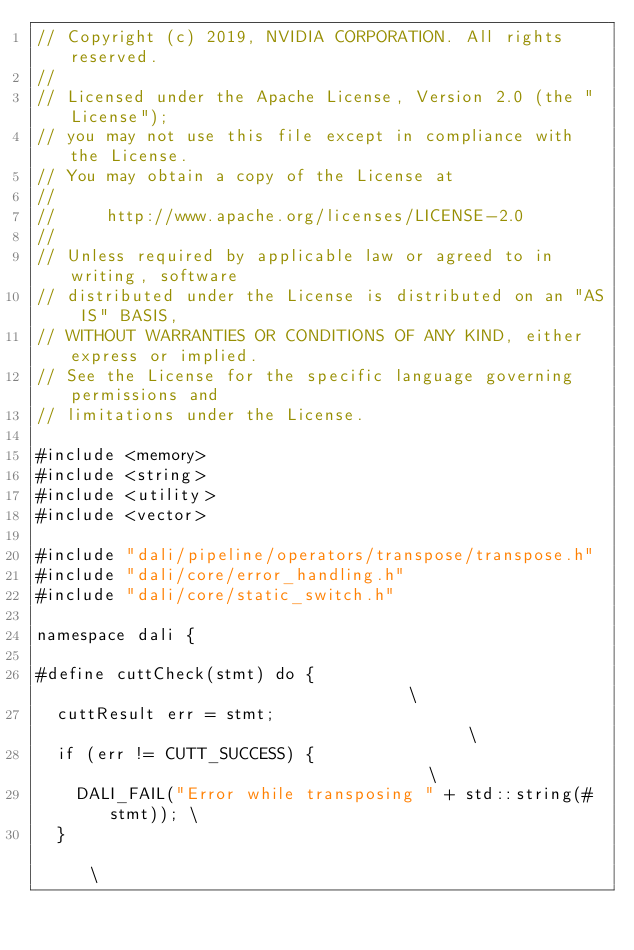<code> <loc_0><loc_0><loc_500><loc_500><_Cuda_>// Copyright (c) 2019, NVIDIA CORPORATION. All rights reserved.
//
// Licensed under the Apache License, Version 2.0 (the "License");
// you may not use this file except in compliance with the License.
// You may obtain a copy of the License at
//
//     http://www.apache.org/licenses/LICENSE-2.0
//
// Unless required by applicable law or agreed to in writing, software
// distributed under the License is distributed on an "AS IS" BASIS,
// WITHOUT WARRANTIES OR CONDITIONS OF ANY KIND, either express or implied.
// See the License for the specific language governing permissions and
// limitations under the License.

#include <memory>
#include <string>
#include <utility>
#include <vector>

#include "dali/pipeline/operators/transpose/transpose.h"
#include "dali/core/error_handling.h"
#include "dali/core/static_switch.h"

namespace dali {

#define cuttCheck(stmt) do {                                   \
  cuttResult err = stmt;                                       \
  if (err != CUTT_SUCCESS) {                                   \
    DALI_FAIL("Error while transposing " + std::string(#stmt)); \
  }                                                            \</code> 